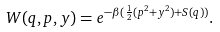Convert formula to latex. <formula><loc_0><loc_0><loc_500><loc_500>W ( q , p , y ) = e ^ { - \beta ( \frac { 1 } { 2 } ( p ^ { 2 } + y ^ { 2 } ) + S ( q ) ) } .</formula> 